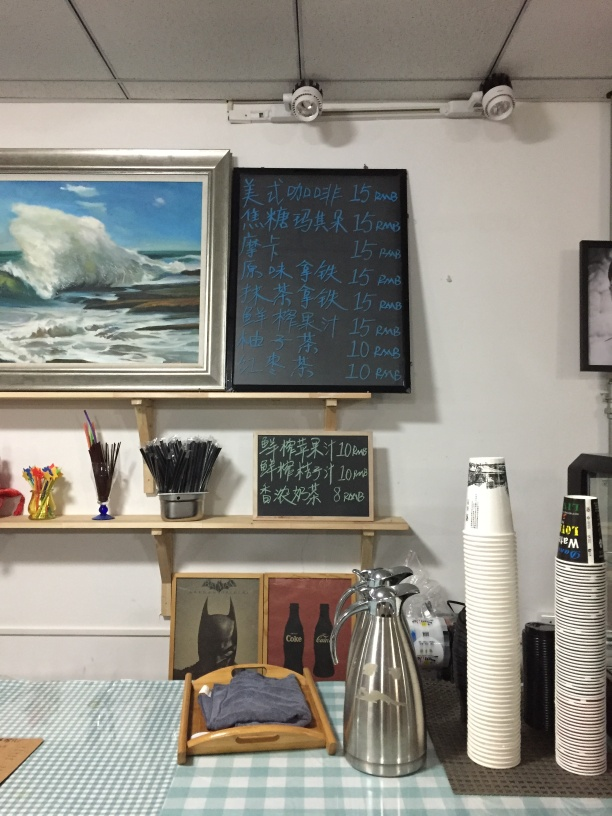What is the overall quality of this image? The overall quality of this image is fair, with adequate lighting and composition that allows the viewer to discern various elements such as the menu boards, the painting, and the items on the counter. However, the perspective is slightly tilted and the image could benefit from a higher resolution to better capture details. 